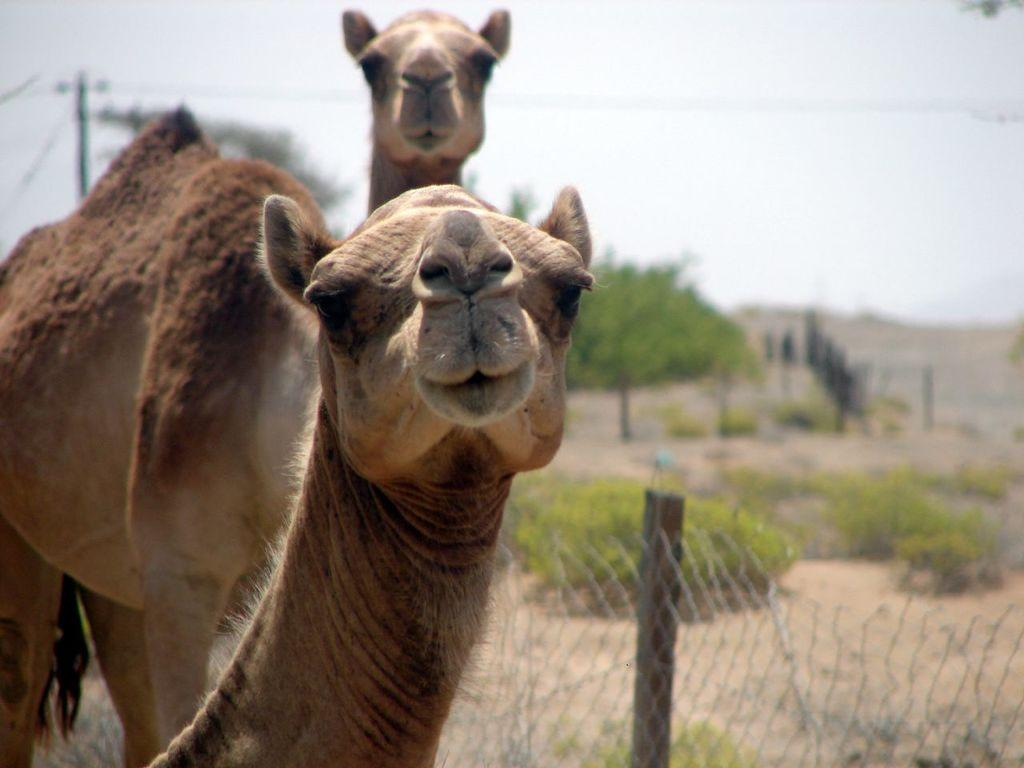What types of living organisms can be seen in the image? There are animals in the image. What can be seen in the background of the image? There are trees in the background of the image. What is the purpose of the pole in the image? The pole's purpose is not specified in the image, but it may be used for supporting wires or other structures. What is the nature of the wires in the image? There are wires in the image, which may be used for transmitting electricity or communication signals. What type of barrier is present in the image? There is a fence in the image, which may be used for marking boundaries or providing security. What is visible at the top of the image? The sky is visible at the top of the image. What impulse is the crook experiencing while standing next to the fence in the image? There is no crook present in the image, and therefore no impulse can be attributed to them. 